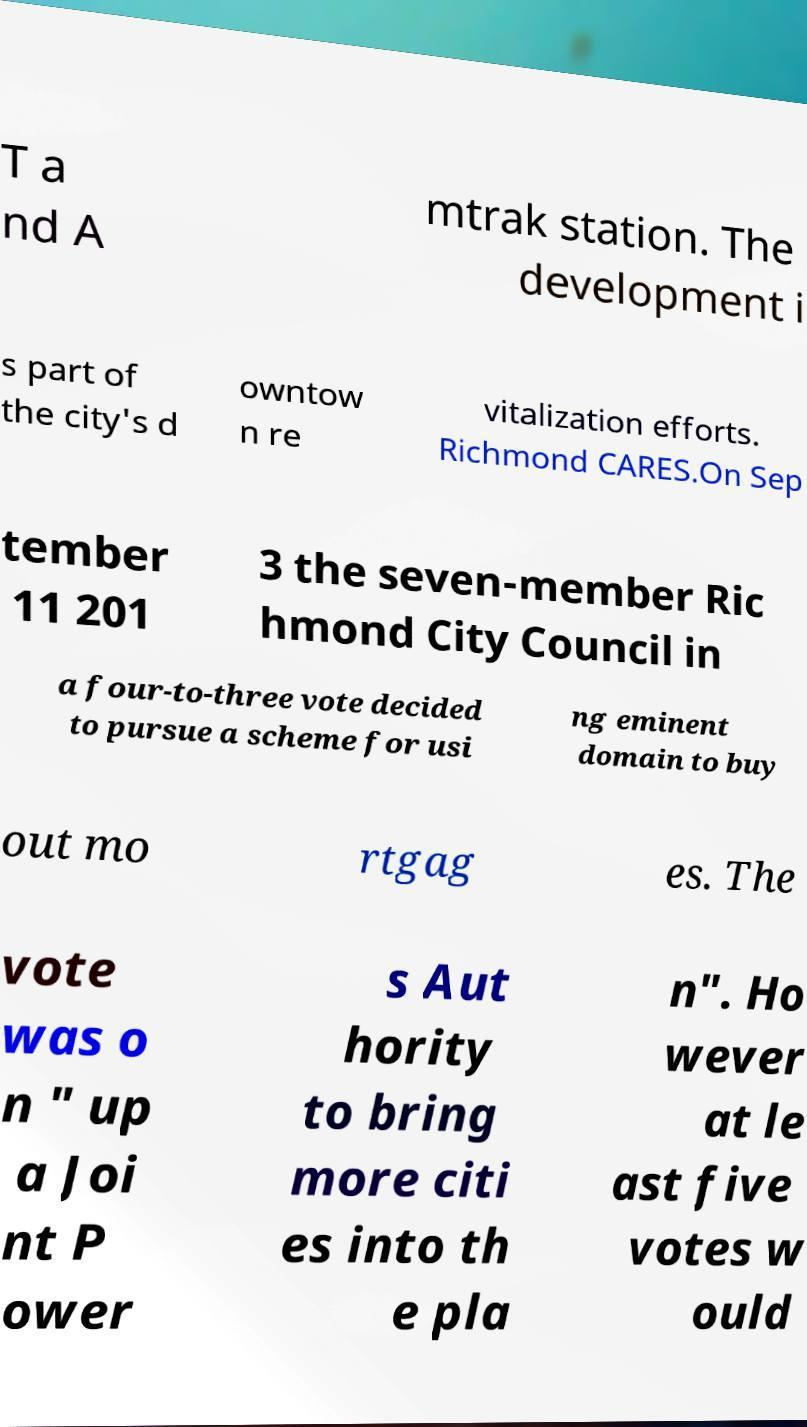What messages or text are displayed in this image? I need them in a readable, typed format. T a nd A mtrak station. The development i s part of the city's d owntow n re vitalization efforts. Richmond CARES.On Sep tember 11 201 3 the seven-member Ric hmond City Council in a four-to-three vote decided to pursue a scheme for usi ng eminent domain to buy out mo rtgag es. The vote was o n " up a Joi nt P ower s Aut hority to bring more citi es into th e pla n". Ho wever at le ast five votes w ould 